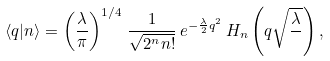Convert formula to latex. <formula><loc_0><loc_0><loc_500><loc_500>\langle q | n \rangle = \left ( \frac { \lambda } { \pi } \right ) ^ { 1 / 4 } \, \frac { 1 } { \sqrt { 2 ^ { n } n ! } } \, e ^ { - \frac { \lambda } { 2 } q ^ { 2 } } \, H _ { n } \left ( q \sqrt { \frac { \lambda } { } } \right ) ,</formula> 